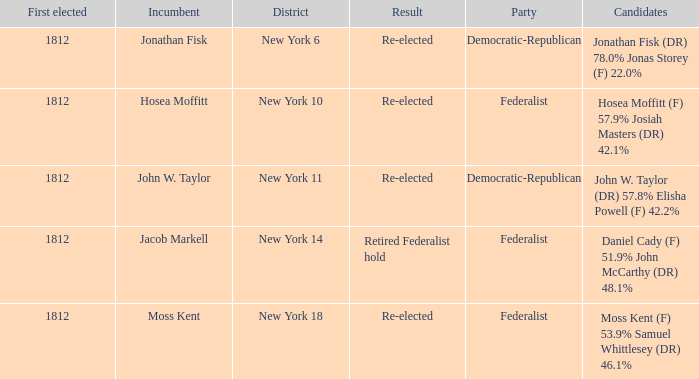Can you parse all the data within this table? {'header': ['First elected', 'Incumbent', 'District', 'Result', 'Party', 'Candidates'], 'rows': [['1812', 'Jonathan Fisk', 'New York 6', 'Re-elected', 'Democratic-Republican', 'Jonathan Fisk (DR) 78.0% Jonas Storey (F) 22.0%'], ['1812', 'Hosea Moffitt', 'New York 10', 'Re-elected', 'Federalist', 'Hosea Moffitt (F) 57.9% Josiah Masters (DR) 42.1%'], ['1812', 'John W. Taylor', 'New York 11', 'Re-elected', 'Democratic-Republican', 'John W. Taylor (DR) 57.8% Elisha Powell (F) 42.2%'], ['1812', 'Jacob Markell', 'New York 14', 'Retired Federalist hold', 'Federalist', 'Daniel Cady (F) 51.9% John McCarthy (DR) 48.1%'], ['1812', 'Moss Kent', 'New York 18', 'Re-elected', 'Federalist', 'Moss Kent (F) 53.9% Samuel Whittlesey (DR) 46.1%']]} Name the first elected for hosea moffitt (f) 57.9% josiah masters (dr) 42.1% 1812.0. 